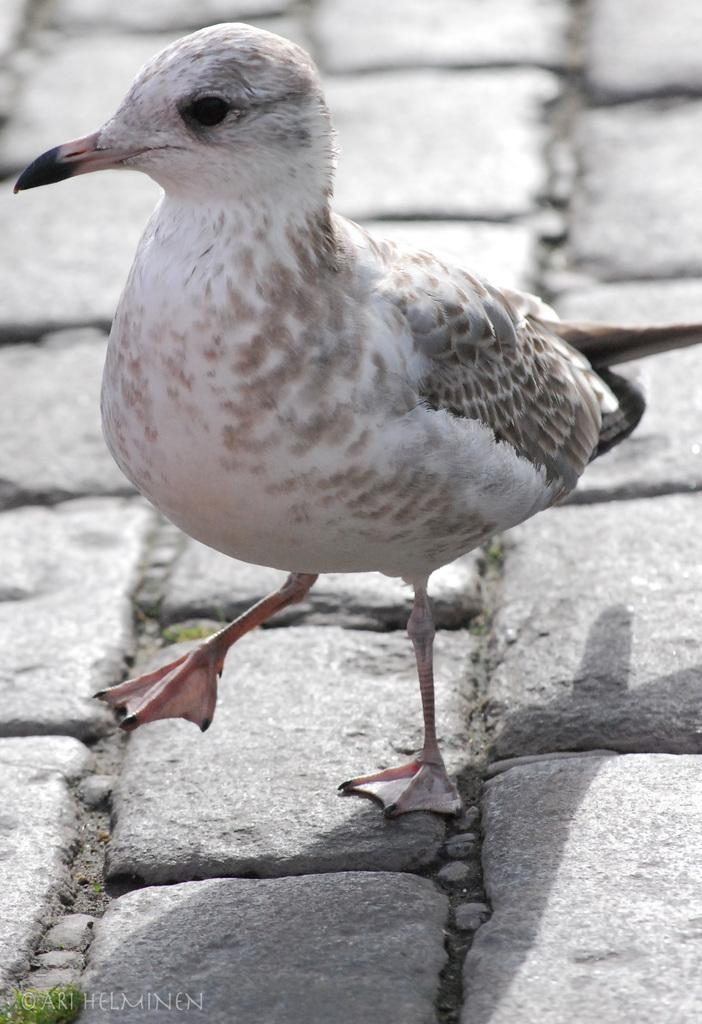What type of animal can be seen in the image? There is a bird in the image. What is the bird doing in the image? The bird is walking on the floor. How many women are accompanying the bird on its trip in the image? There is no reference to a trip or any women in the image; it features a bird walking on the floor. 